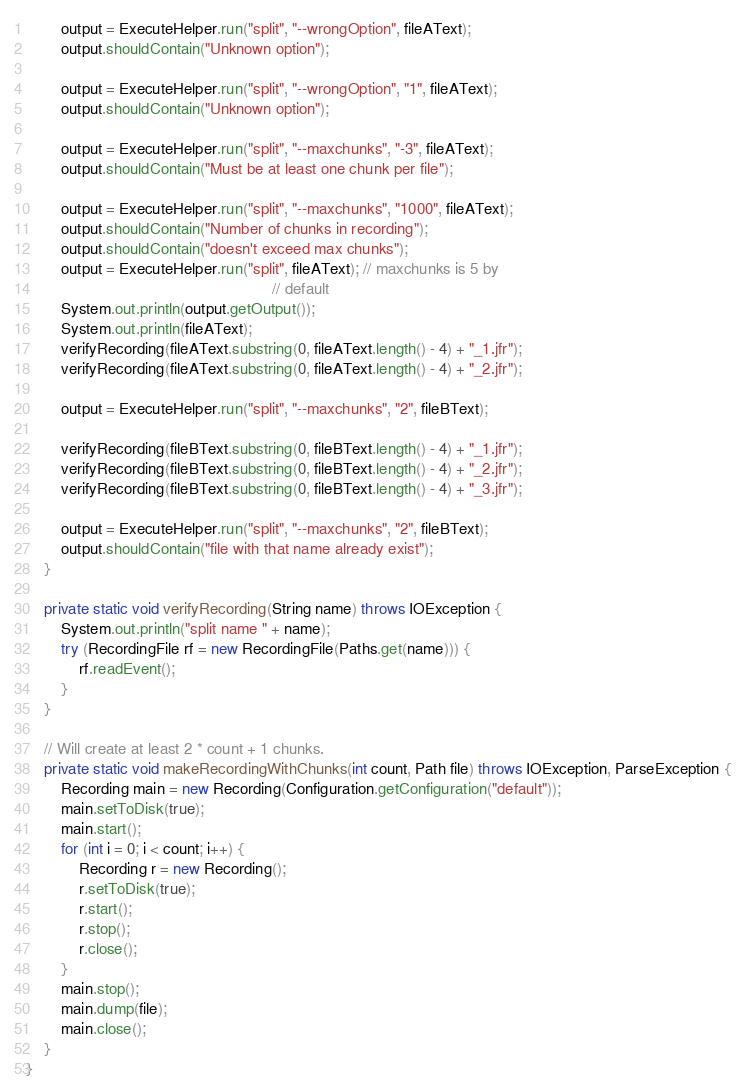<code> <loc_0><loc_0><loc_500><loc_500><_Java_>        output = ExecuteHelper.run("split", "--wrongOption", fileAText);
        output.shouldContain("Unknown option");

        output = ExecuteHelper.run("split", "--wrongOption", "1", fileAText);
        output.shouldContain("Unknown option");

        output = ExecuteHelper.run("split", "--maxchunks", "-3", fileAText);
        output.shouldContain("Must be at least one chunk per file");

        output = ExecuteHelper.run("split", "--maxchunks", "1000", fileAText);
        output.shouldContain("Number of chunks in recording");
        output.shouldContain("doesn't exceed max chunks");
        output = ExecuteHelper.run("split", fileAText); // maxchunks is 5 by
                                                        // default
        System.out.println(output.getOutput());
        System.out.println(fileAText);
        verifyRecording(fileAText.substring(0, fileAText.length() - 4) + "_1.jfr");
        verifyRecording(fileAText.substring(0, fileAText.length() - 4) + "_2.jfr");

        output = ExecuteHelper.run("split", "--maxchunks", "2", fileBText);

        verifyRecording(fileBText.substring(0, fileBText.length() - 4) + "_1.jfr");
        verifyRecording(fileBText.substring(0, fileBText.length() - 4) + "_2.jfr");
        verifyRecording(fileBText.substring(0, fileBText.length() - 4) + "_3.jfr");

        output = ExecuteHelper.run("split", "--maxchunks", "2", fileBText);
        output.shouldContain("file with that name already exist");
    }

    private static void verifyRecording(String name) throws IOException {
        System.out.println("split name " + name);
        try (RecordingFile rf = new RecordingFile(Paths.get(name))) {
            rf.readEvent();
        }
    }

    // Will create at least 2 * count + 1 chunks.
    private static void makeRecordingWithChunks(int count, Path file) throws IOException, ParseException {
        Recording main = new Recording(Configuration.getConfiguration("default"));
        main.setToDisk(true);
        main.start();
        for (int i = 0; i < count; i++) {
            Recording r = new Recording();
            r.setToDisk(true);
            r.start();
            r.stop();
            r.close();
        }
        main.stop();
        main.dump(file);
        main.close();
    }
}
</code> 